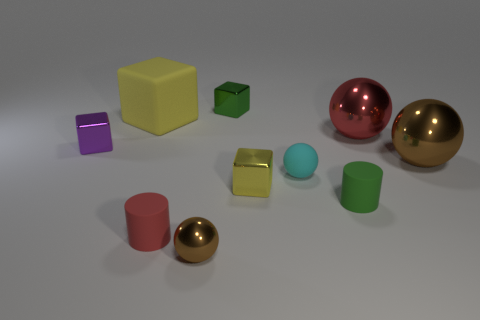There is a yellow thing that is the same size as the cyan thing; what is it made of?
Give a very brief answer. Metal. What number of other things are there of the same material as the cyan ball
Your answer should be very brief. 3. Is the shape of the red object that is on the right side of the tiny green rubber object the same as the object that is to the right of the big red ball?
Offer a very short reply. Yes. How many other things are there of the same color as the tiny metallic ball?
Your answer should be compact. 1. Is the material of the small purple thing that is behind the small yellow object the same as the yellow object in front of the large yellow matte thing?
Your response must be concise. Yes. Are there the same number of tiny brown spheres to the left of the small brown sphere and tiny shiny balls that are behind the big yellow thing?
Keep it short and to the point. Yes. There is a brown sphere in front of the big brown sphere; what is its material?
Provide a short and direct response. Metal. Is there anything else that has the same size as the yellow rubber thing?
Make the answer very short. Yes. Is the number of large rubber objects less than the number of metal things?
Your response must be concise. Yes. What shape is the large object that is both right of the large yellow block and to the left of the big brown sphere?
Ensure brevity in your answer.  Sphere. 